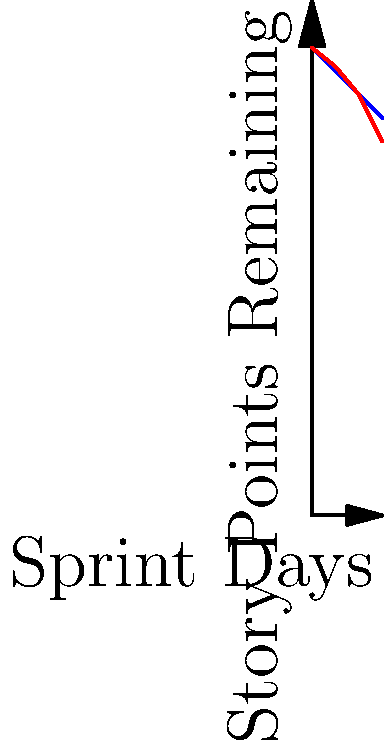As a business owner focused on cost-effective project management, analyze the burndown chart above. If the project has a total of 100 story points and is planned for a 15-day sprint, what is the team's average velocity (story points completed per day) between days 10 and 15, and how does this compare to the ideal velocity? To answer this question, we need to follow these steps:

1. Calculate the ideal velocity:
   - Total story points: 100
   - Sprint duration: 15 days
   - Ideal velocity = 100 / 15 = 6.67 story points per day

2. Calculate the actual velocity between days 10 and 15:
   - Story points remaining at day 10: 90
   - Story points remaining at day 15: 80
   - Story points completed = 90 - 80 = 10
   - Days elapsed = 15 - 10 = 5
   - Actual velocity = 10 / 5 = 2 story points per day

3. Compare the actual velocity to the ideal velocity:
   - Actual velocity (2) is lower than the ideal velocity (6.67)
   - The team is completing work at a rate of 2 / 6.67 ≈ 0.30 or 30% of the ideal pace

4. Interpret the results:
   - The team's velocity between days 10 and 15 is significantly lower than the ideal velocity
   - This indicates that the project is behind schedule and may not be completed within the planned 15-day sprint
Answer: 2 story points/day; 30% of ideal pace 